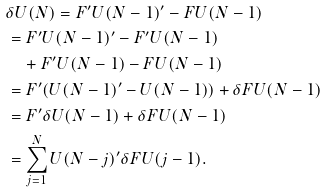Convert formula to latex. <formula><loc_0><loc_0><loc_500><loc_500>& \delta U ( N ) = F ^ { \prime } U ( N - 1 ) ^ { \prime } - F U ( N - 1 ) \\ & = F ^ { \prime } U ( N - 1 ) ^ { \prime } - F ^ { \prime } U ( N - 1 ) \\ & \quad + F ^ { \prime } U ( N - 1 ) - F U ( N - 1 ) \\ & = F ^ { \prime } ( U ( N - 1 ) ^ { \prime } - U ( N - 1 ) ) + \delta F U ( N - 1 ) \\ & = F ^ { \prime } \delta U ( N - 1 ) + \delta F U ( N - 1 ) \\ & = \sum _ { j = 1 } ^ { N } U ( N - j ) ^ { \prime } \delta F U ( j - 1 ) . \\</formula> 